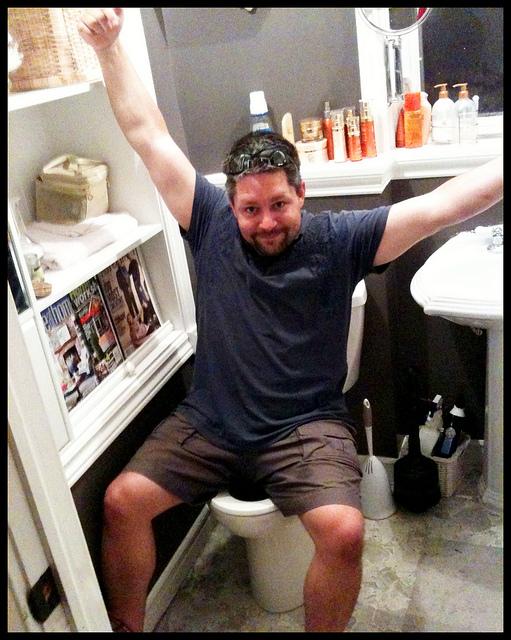What is the man sitting on?
Quick response, please. Toilet. What room is this?
Write a very short answer. Bathroom. What is on this persons head?
Write a very short answer. Glasses. 